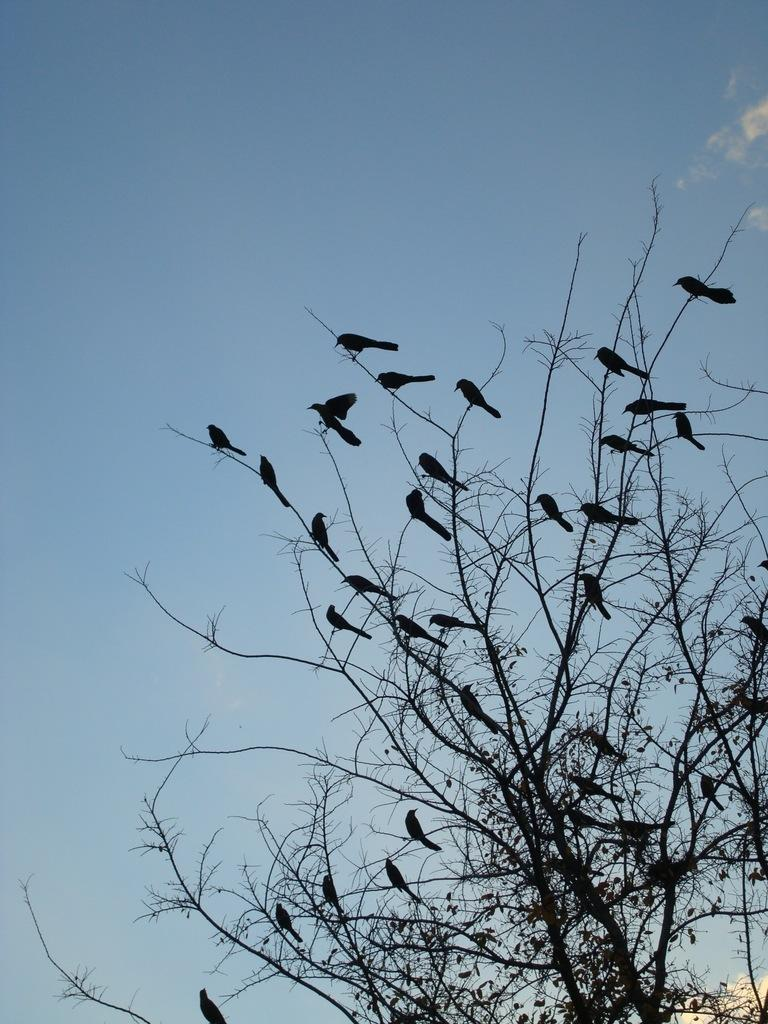What type of animals can be seen in the image? There are birds in the image. Where are the birds located in the image? The birds are on the branches of a tree. What can be seen in the background of the image? The sky is visible in the background of the image. How many mittens are hanging from the branches of the tree in the image? There are no mittens present in the image; it features birds on the branches of a tree. Can you describe the interaction between the deer and the birds in the image? There are no deer present in the image; it features only birds on the branches of a tree. 